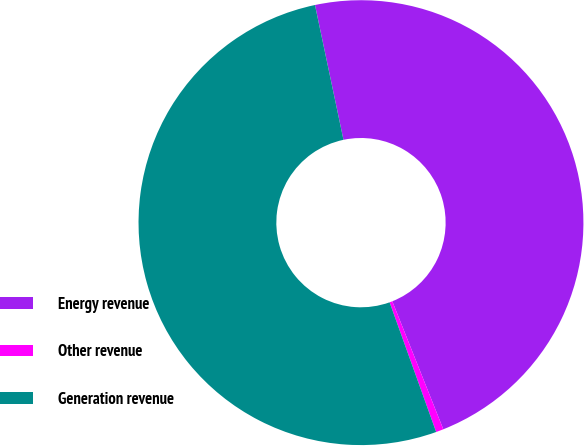<chart> <loc_0><loc_0><loc_500><loc_500><pie_chart><fcel>Energy revenue<fcel>Other revenue<fcel>Generation revenue<nl><fcel>47.28%<fcel>0.55%<fcel>52.17%<nl></chart> 